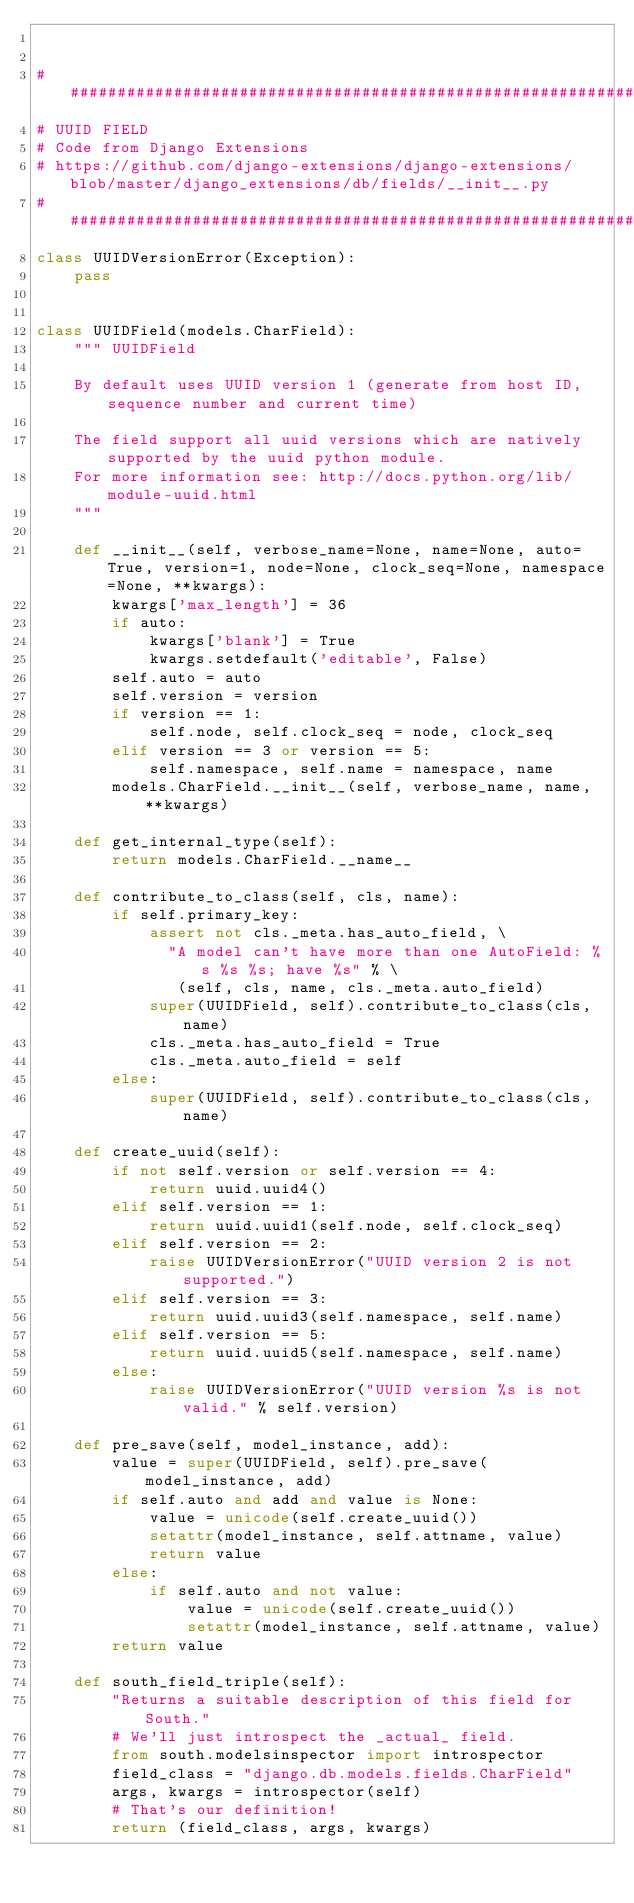Convert code to text. <code><loc_0><loc_0><loc_500><loc_500><_Python_>

##################################################################################################################
# UUID FIELD
# Code from Django Extensions
# https://github.com/django-extensions/django-extensions/blob/master/django_extensions/db/fields/__init__.py
##################################################################################################################
class UUIDVersionError(Exception):
    pass


class UUIDField(models.CharField):
    """ UUIDField

    By default uses UUID version 1 (generate from host ID, sequence number and current time)

    The field support all uuid versions which are natively supported by the uuid python module.
    For more information see: http://docs.python.org/lib/module-uuid.html
    """

    def __init__(self, verbose_name=None, name=None, auto=True, version=1, node=None, clock_seq=None, namespace=None, **kwargs):
        kwargs['max_length'] = 36
        if auto:
            kwargs['blank'] = True
            kwargs.setdefault('editable', False)
        self.auto = auto
        self.version = version
        if version == 1:
            self.node, self.clock_seq = node, clock_seq
        elif version == 3 or version == 5:
            self.namespace, self.name = namespace, name
        models.CharField.__init__(self, verbose_name, name, **kwargs)

    def get_internal_type(self):
        return models.CharField.__name__

    def contribute_to_class(self, cls, name):
        if self.primary_key:
            assert not cls._meta.has_auto_field, \
              "A model can't have more than one AutoField: %s %s %s; have %s" % \
               (self, cls, name, cls._meta.auto_field)
            super(UUIDField, self).contribute_to_class(cls, name)
            cls._meta.has_auto_field = True
            cls._meta.auto_field = self
        else:
            super(UUIDField, self).contribute_to_class(cls, name)

    def create_uuid(self):
        if not self.version or self.version == 4:
            return uuid.uuid4()
        elif self.version == 1:
            return uuid.uuid1(self.node, self.clock_seq)
        elif self.version == 2:
            raise UUIDVersionError("UUID version 2 is not supported.")
        elif self.version == 3:
            return uuid.uuid3(self.namespace, self.name)
        elif self.version == 5:
            return uuid.uuid5(self.namespace, self.name)
        else:
            raise UUIDVersionError("UUID version %s is not valid." % self.version)

    def pre_save(self, model_instance, add):
        value = super(UUIDField, self).pre_save(model_instance, add)
        if self.auto and add and value is None:
            value = unicode(self.create_uuid())
            setattr(model_instance, self.attname, value)
            return value
        else:
            if self.auto and not value:
                value = unicode(self.create_uuid())
                setattr(model_instance, self.attname, value)
        return value

    def south_field_triple(self):
        "Returns a suitable description of this field for South."
        # We'll just introspect the _actual_ field.
        from south.modelsinspector import introspector
        field_class = "django.db.models.fields.CharField"
        args, kwargs = introspector(self)
        # That's our definition!
        return (field_class, args, kwargs)
</code> 